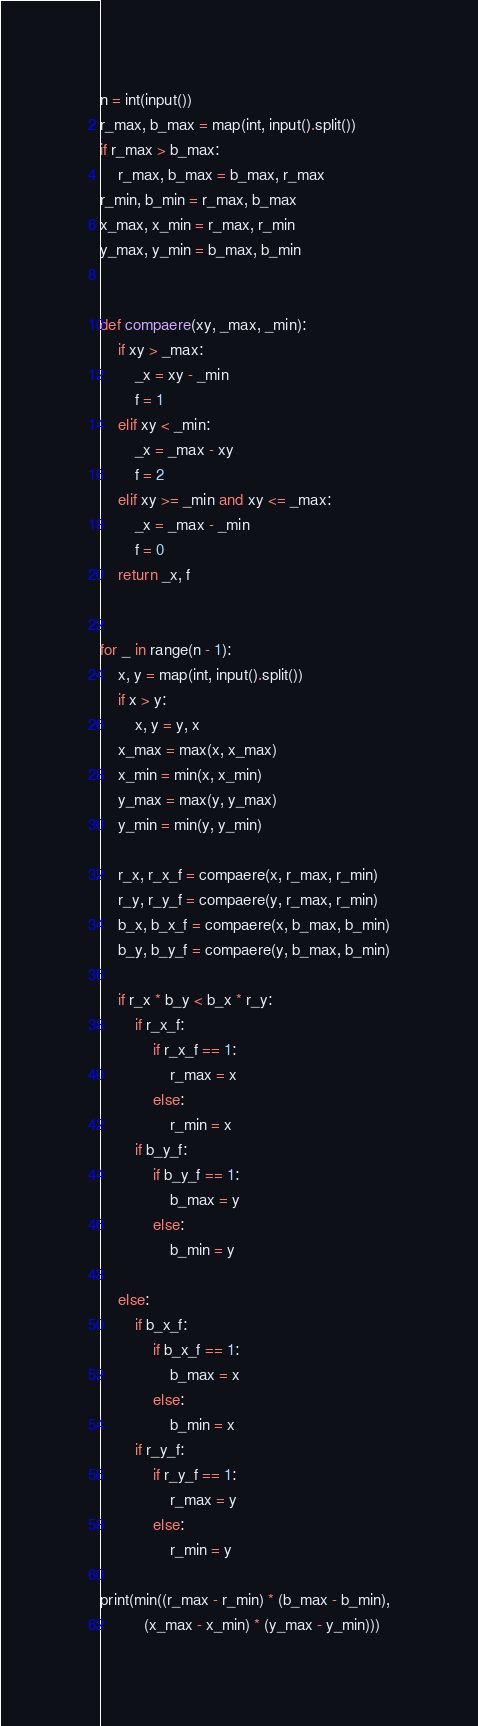<code> <loc_0><loc_0><loc_500><loc_500><_Python_>n = int(input())
r_max, b_max = map(int, input().split())
if r_max > b_max:
    r_max, b_max = b_max, r_max
r_min, b_min = r_max, b_max
x_max, x_min = r_max, r_min
y_max, y_min = b_max, b_min


def compaere(xy, _max, _min):
    if xy > _max:
        _x = xy - _min
        f = 1
    elif xy < _min:
        _x = _max - xy
        f = 2
    elif xy >= _min and xy <= _max:
        _x = _max - _min
        f = 0
    return _x, f


for _ in range(n - 1):
    x, y = map(int, input().split())
    if x > y:
        x, y = y, x
    x_max = max(x, x_max)
    x_min = min(x, x_min)
    y_max = max(y, y_max)
    y_min = min(y, y_min)

    r_x, r_x_f = compaere(x, r_max, r_min)
    r_y, r_y_f = compaere(y, r_max, r_min)
    b_x, b_x_f = compaere(x, b_max, b_min)
    b_y, b_y_f = compaere(y, b_max, b_min)

    if r_x * b_y < b_x * r_y:
        if r_x_f:
            if r_x_f == 1:
                r_max = x
            else:
                r_min = x
        if b_y_f:
            if b_y_f == 1:
                b_max = y
            else:
                b_min = y

    else:
        if b_x_f:
            if b_x_f == 1:
                b_max = x
            else:
                b_min = x
        if r_y_f:
            if r_y_f == 1:
                r_max = y
            else:
                r_min = y

print(min((r_max - r_min) * (b_max - b_min),
          (x_max - x_min) * (y_max - y_min)))
</code> 